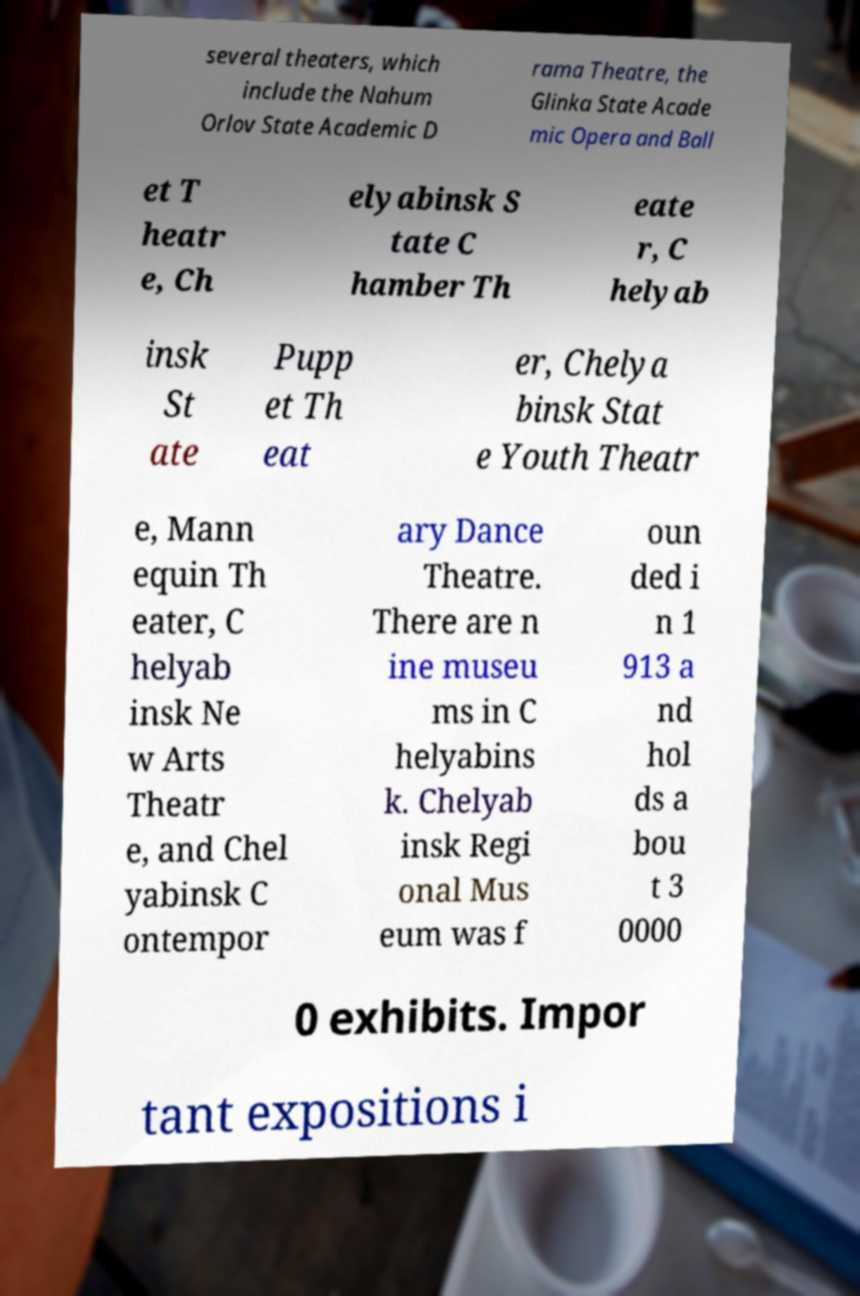There's text embedded in this image that I need extracted. Can you transcribe it verbatim? several theaters, which include the Nahum Orlov State Academic D rama Theatre, the Glinka State Acade mic Opera and Ball et T heatr e, Ch elyabinsk S tate C hamber Th eate r, C helyab insk St ate Pupp et Th eat er, Chelya binsk Stat e Youth Theatr e, Mann equin Th eater, C helyab insk Ne w Arts Theatr e, and Chel yabinsk C ontempor ary Dance Theatre. There are n ine museu ms in C helyabins k. Chelyab insk Regi onal Mus eum was f oun ded i n 1 913 a nd hol ds a bou t 3 0000 0 exhibits. Impor tant expositions i 